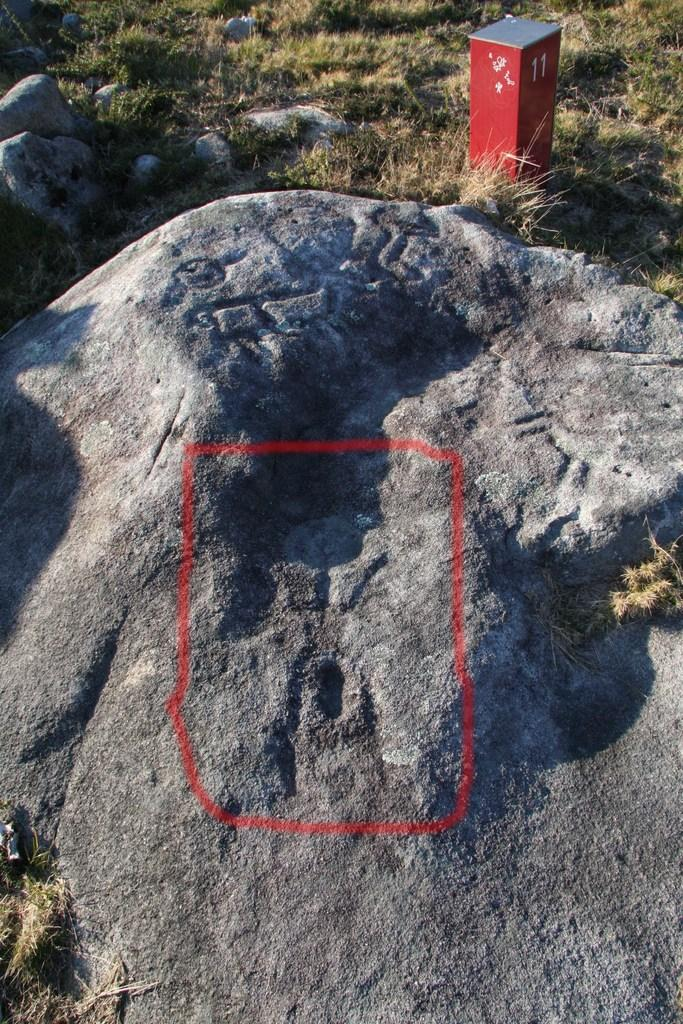What type of natural elements can be seen in the image? There are rocks and stone in the image. What type of vegetation is visible in the background of the image? There is grass visible in the background of the image. How many eggs are being held by the person in the image? There is no person present in the image, and therefore no eggs being held. 